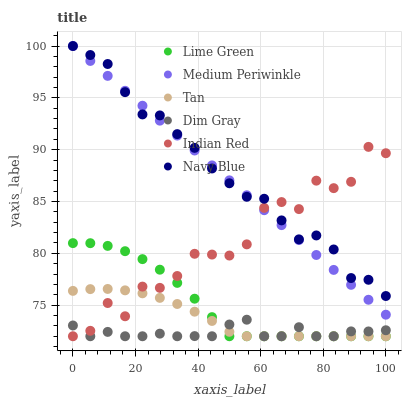Does Dim Gray have the minimum area under the curve?
Answer yes or no. Yes. Does Navy Blue have the maximum area under the curve?
Answer yes or no. Yes. Does Medium Periwinkle have the minimum area under the curve?
Answer yes or no. No. Does Medium Periwinkle have the maximum area under the curve?
Answer yes or no. No. Is Medium Periwinkle the smoothest?
Answer yes or no. Yes. Is Indian Red the roughest?
Answer yes or no. Yes. Is Navy Blue the smoothest?
Answer yes or no. No. Is Navy Blue the roughest?
Answer yes or no. No. Does Dim Gray have the lowest value?
Answer yes or no. Yes. Does Medium Periwinkle have the lowest value?
Answer yes or no. No. Does Medium Periwinkle have the highest value?
Answer yes or no. Yes. Does Indian Red have the highest value?
Answer yes or no. No. Is Lime Green less than Navy Blue?
Answer yes or no. Yes. Is Navy Blue greater than Lime Green?
Answer yes or no. Yes. Does Lime Green intersect Dim Gray?
Answer yes or no. Yes. Is Lime Green less than Dim Gray?
Answer yes or no. No. Is Lime Green greater than Dim Gray?
Answer yes or no. No. Does Lime Green intersect Navy Blue?
Answer yes or no. No. 